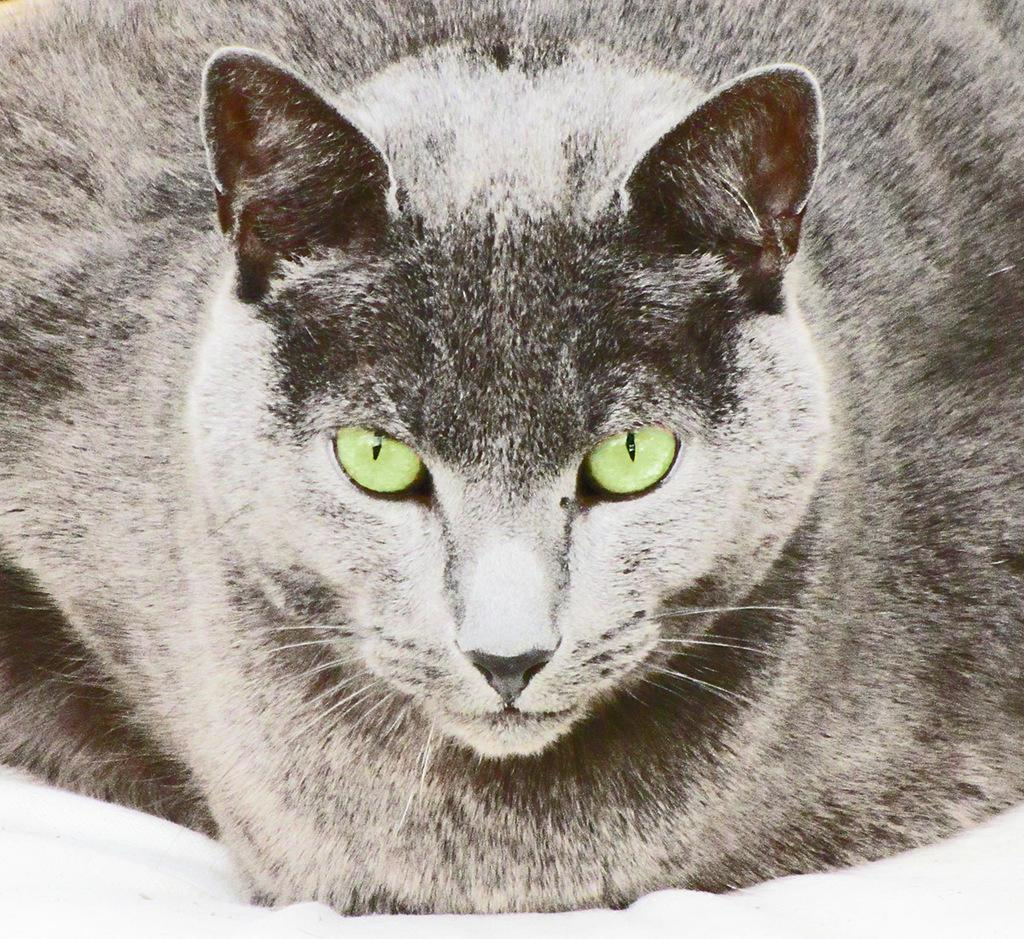What animal is present in the image? There is a cat in the image. What is the cat doing in the image? The cat is looking at one side. What color scheme is used for the cat in the image? The cat is in black and white color. What color are the cat's eyes in the image? The cat has green color eyes. How many plastic steps can be seen in the image? There are no plastic steps present in the image. What type of dime is visible in the image? There is no dime present in the image. 